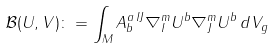<formula> <loc_0><loc_0><loc_500><loc_500>\mathcal { B } ( U , V ) \colon = \int _ { M } A _ { b } ^ { a \, I J } \nabla _ { I } ^ { m } U ^ { b } \nabla _ { J } ^ { m } U ^ { b } \, d V _ { g }</formula> 